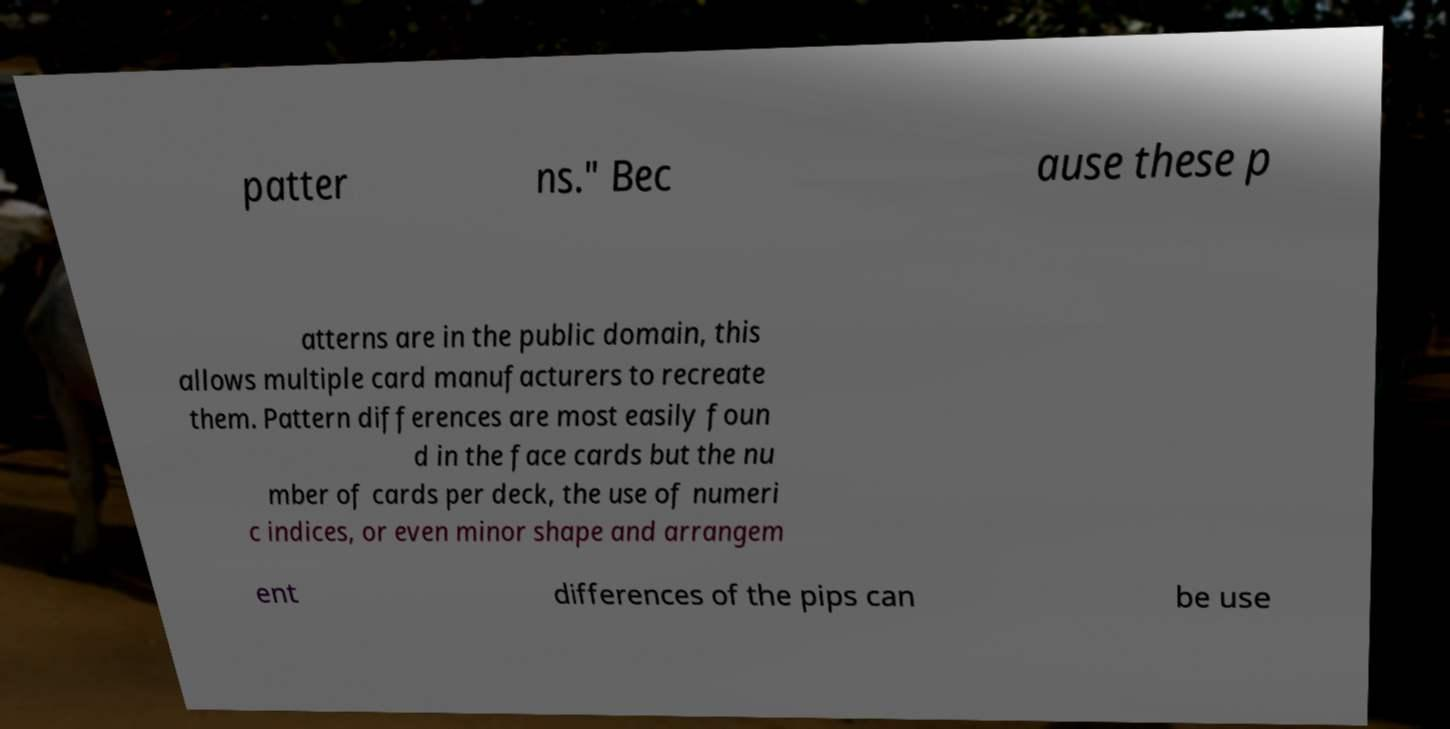For documentation purposes, I need the text within this image transcribed. Could you provide that? patter ns." Bec ause these p atterns are in the public domain, this allows multiple card manufacturers to recreate them. Pattern differences are most easily foun d in the face cards but the nu mber of cards per deck, the use of numeri c indices, or even minor shape and arrangem ent differences of the pips can be use 